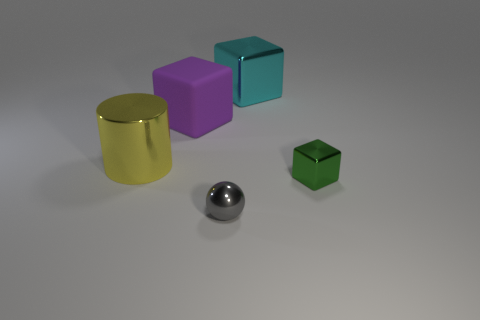There is a large metallic cylinder; does it have the same color as the tiny object in front of the green metallic cube?
Your answer should be compact. No. Are there more gray things behind the big purple block than matte blocks?
Your response must be concise. No. How many objects are metal cubes that are in front of the big yellow object or things that are in front of the tiny green cube?
Ensure brevity in your answer.  2. The yellow cylinder that is made of the same material as the small gray thing is what size?
Offer a terse response. Large. There is a tiny object that is right of the metal ball; does it have the same shape as the cyan thing?
Your answer should be compact. Yes. How many yellow objects are either tiny metal blocks or big metal cylinders?
Your response must be concise. 1. What number of other objects are there of the same shape as the green shiny thing?
Ensure brevity in your answer.  2. What shape is the metallic object that is in front of the big yellow cylinder and behind the tiny sphere?
Provide a succinct answer. Cube. Are there any cyan metallic blocks behind the small green shiny object?
Make the answer very short. Yes. There is a purple matte object that is the same shape as the green thing; what size is it?
Your response must be concise. Large. 